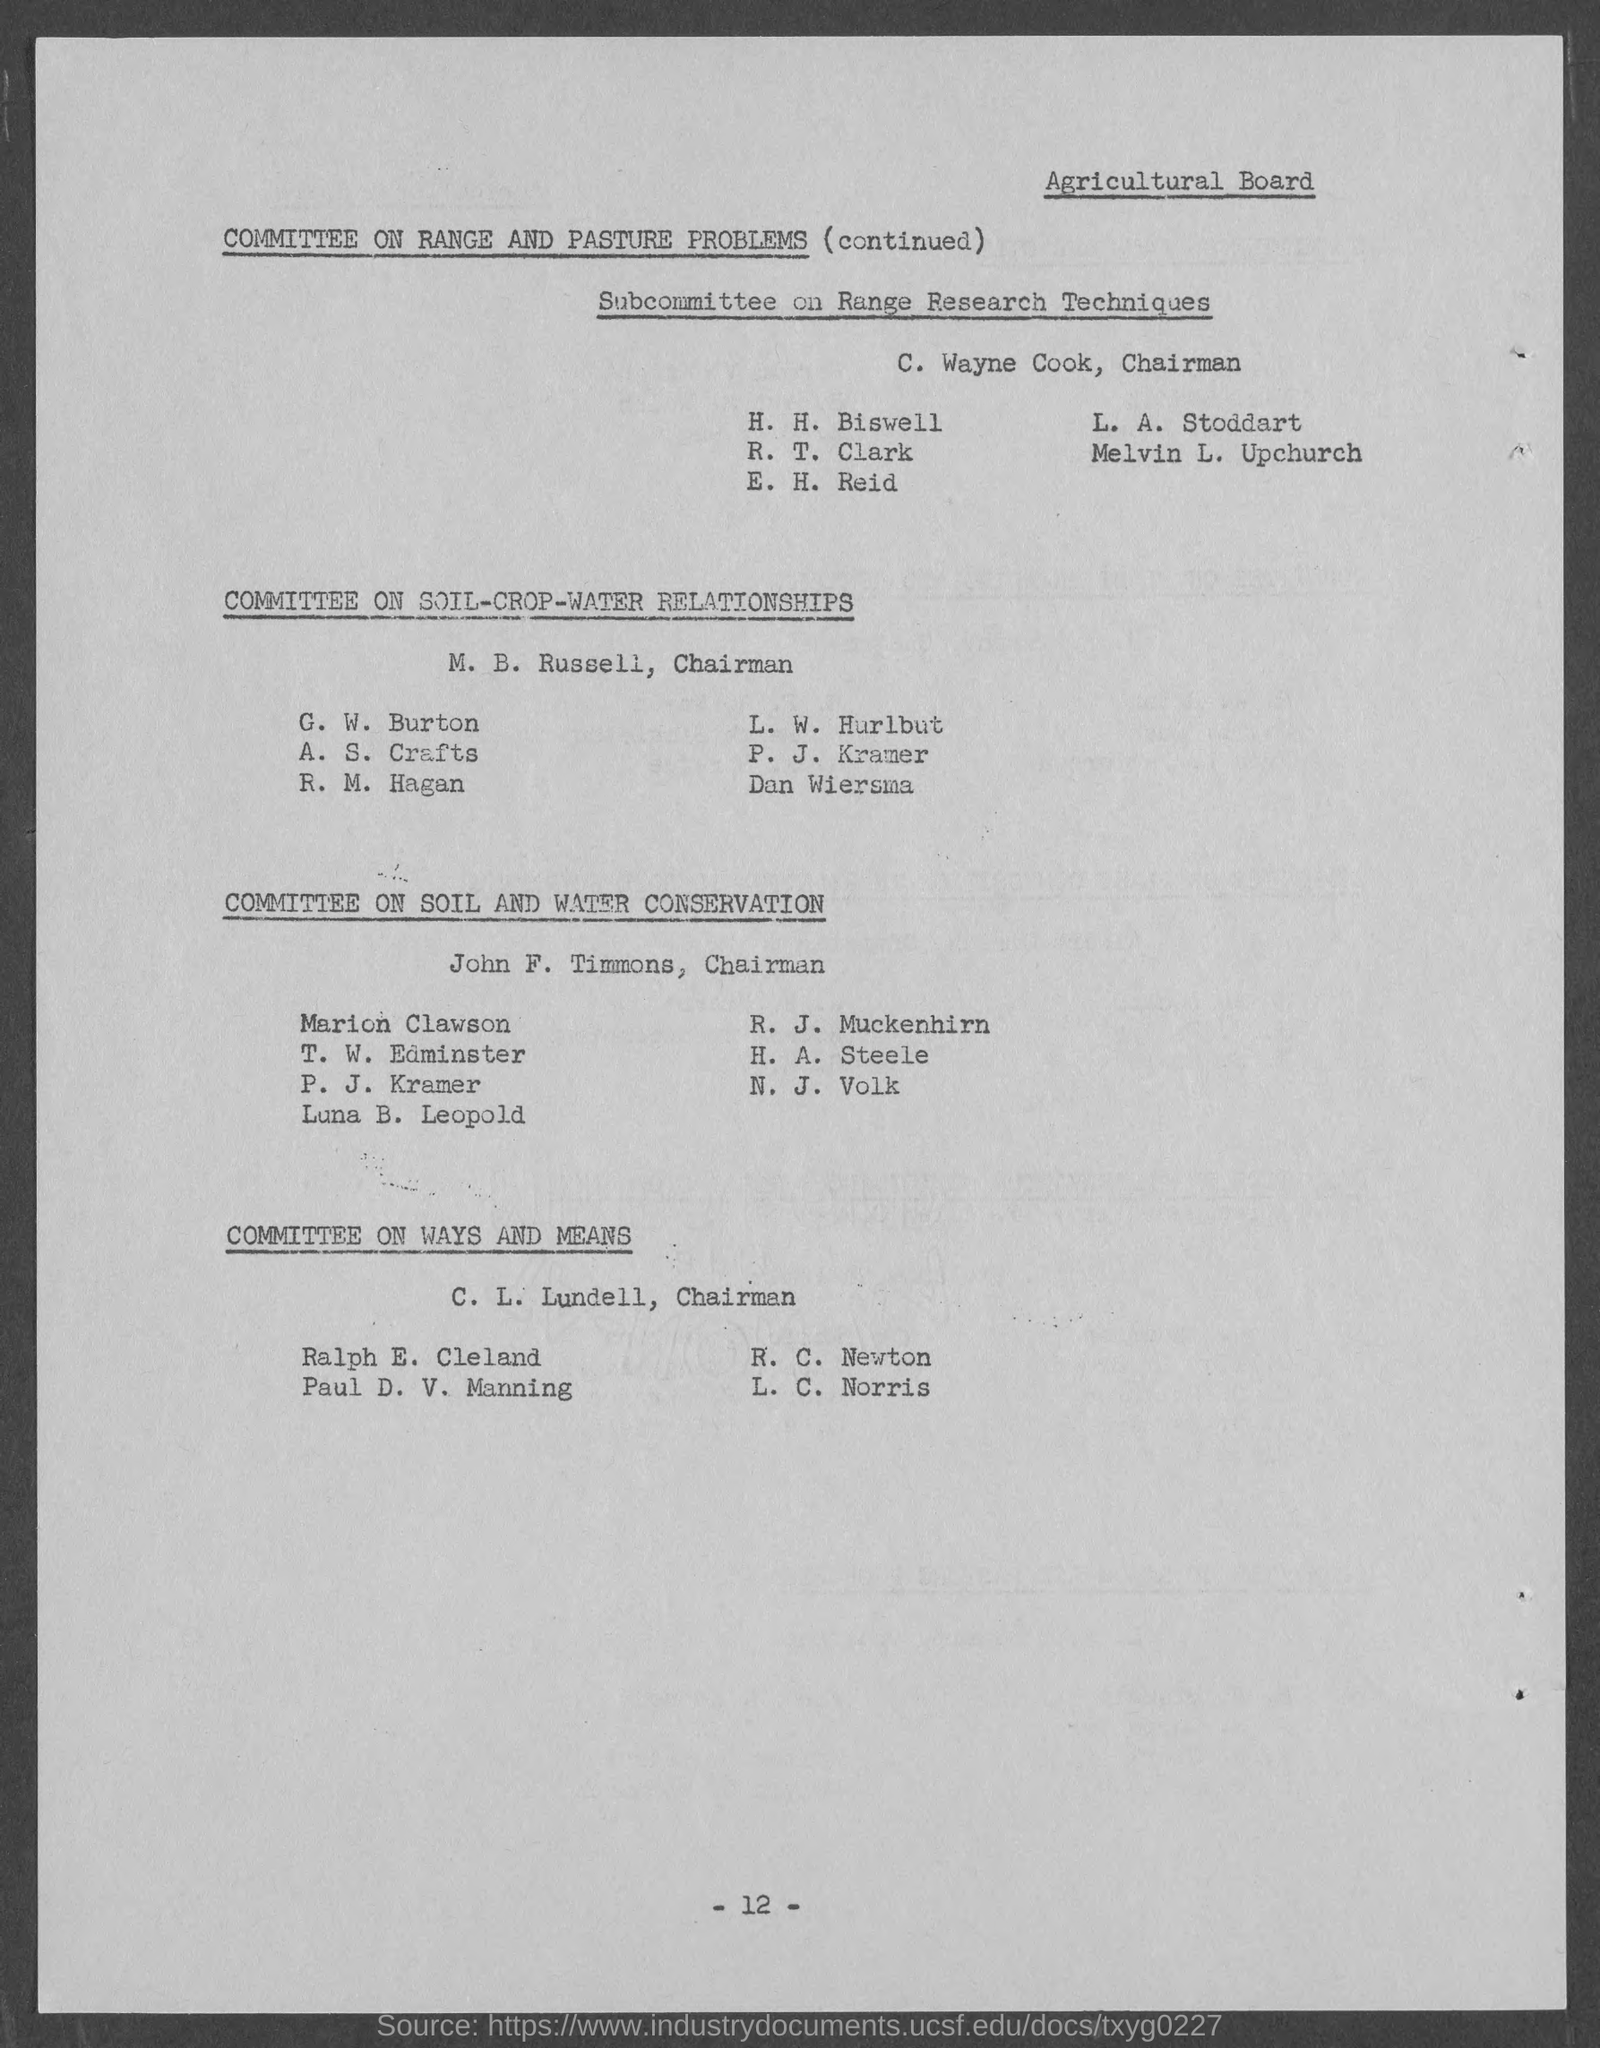Draw attention to some important aspects in this diagram. The chairman of the subcommittee on range research techniques is C. Wayne Cook. John F. Timmons is the chairman of the committee on soil and water conservation. The Chairman of the committee of ways and means is C. L. Lundell. The page number mentioned in this document is 12. 